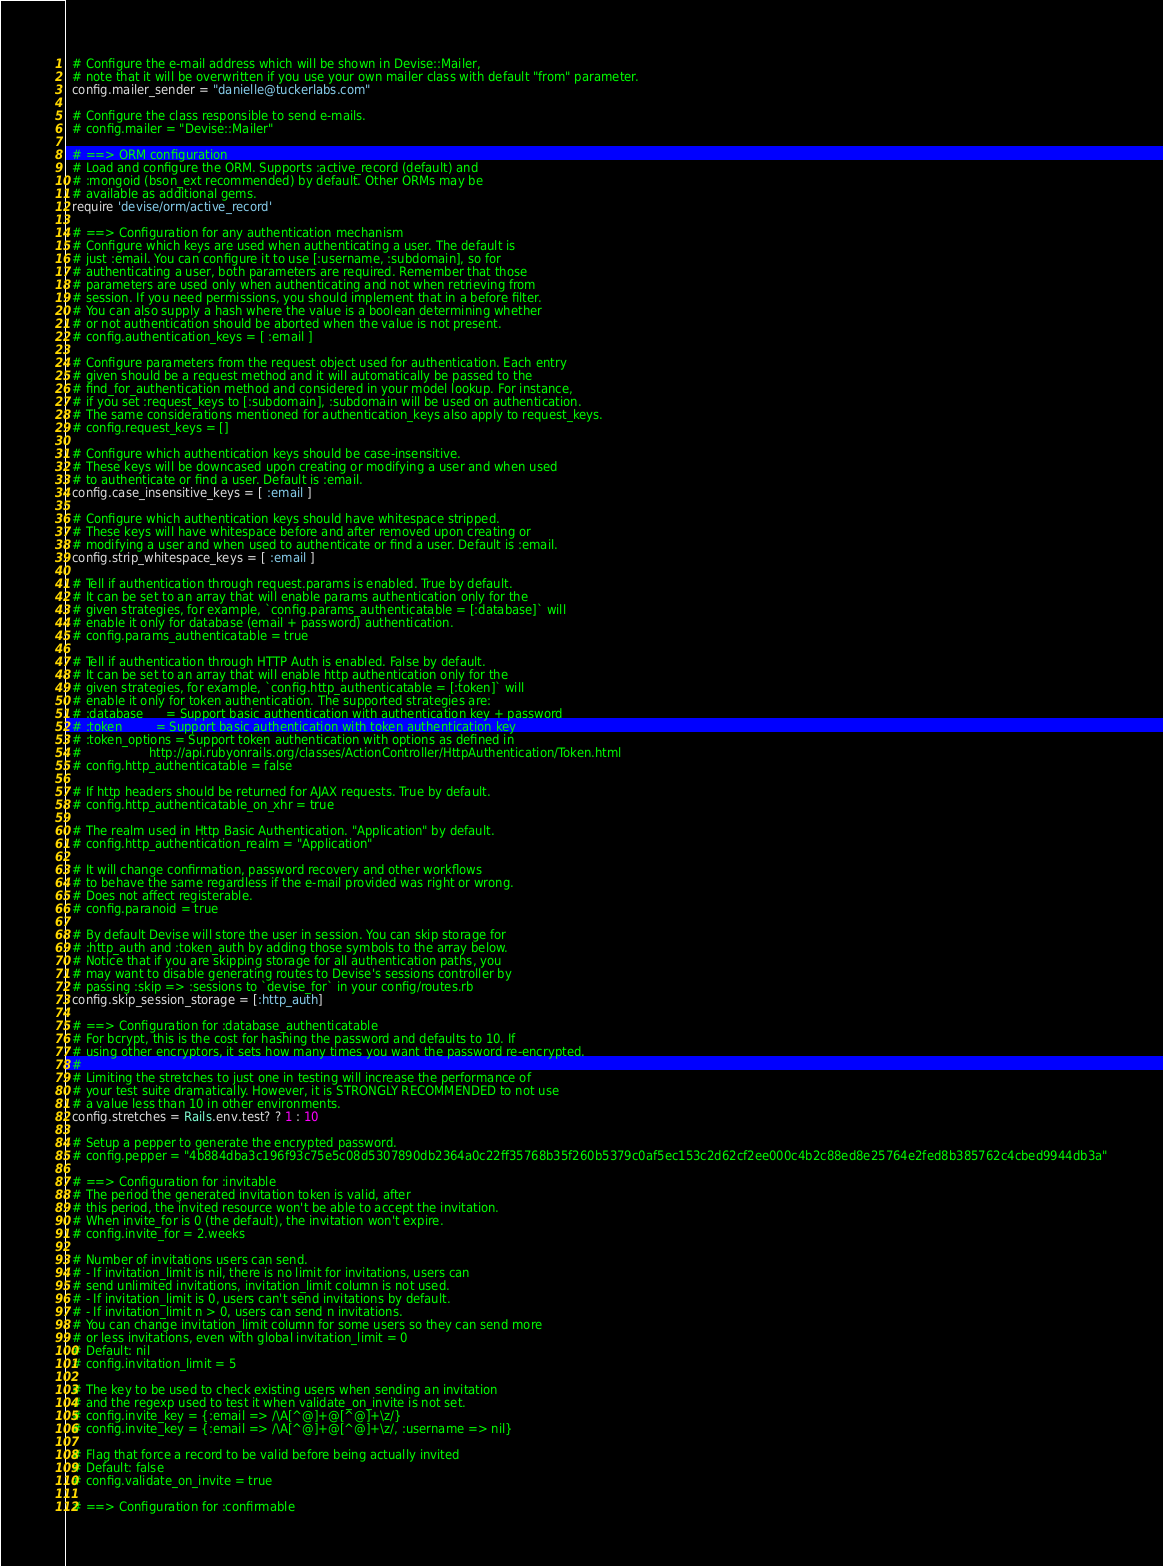<code> <loc_0><loc_0><loc_500><loc_500><_Ruby_>  # Configure the e-mail address which will be shown in Devise::Mailer,
  # note that it will be overwritten if you use your own mailer class with default "from" parameter.
  config.mailer_sender = "danielle@tuckerlabs.com"

  # Configure the class responsible to send e-mails.
  # config.mailer = "Devise::Mailer"

  # ==> ORM configuration
  # Load and configure the ORM. Supports :active_record (default) and
  # :mongoid (bson_ext recommended) by default. Other ORMs may be
  # available as additional gems.
  require 'devise/orm/active_record'

  # ==> Configuration for any authentication mechanism
  # Configure which keys are used when authenticating a user. The default is
  # just :email. You can configure it to use [:username, :subdomain], so for
  # authenticating a user, both parameters are required. Remember that those
  # parameters are used only when authenticating and not when retrieving from
  # session. If you need permissions, you should implement that in a before filter.
  # You can also supply a hash where the value is a boolean determining whether
  # or not authentication should be aborted when the value is not present.
  # config.authentication_keys = [ :email ]

  # Configure parameters from the request object used for authentication. Each entry
  # given should be a request method and it will automatically be passed to the
  # find_for_authentication method and considered in your model lookup. For instance,
  # if you set :request_keys to [:subdomain], :subdomain will be used on authentication.
  # The same considerations mentioned for authentication_keys also apply to request_keys.
  # config.request_keys = []

  # Configure which authentication keys should be case-insensitive.
  # These keys will be downcased upon creating or modifying a user and when used
  # to authenticate or find a user. Default is :email.
  config.case_insensitive_keys = [ :email ]

  # Configure which authentication keys should have whitespace stripped.
  # These keys will have whitespace before and after removed upon creating or
  # modifying a user and when used to authenticate or find a user. Default is :email.
  config.strip_whitespace_keys = [ :email ]

  # Tell if authentication through request.params is enabled. True by default.
  # It can be set to an array that will enable params authentication only for the
  # given strategies, for example, `config.params_authenticatable = [:database]` will
  # enable it only for database (email + password) authentication.
  # config.params_authenticatable = true

  # Tell if authentication through HTTP Auth is enabled. False by default.
  # It can be set to an array that will enable http authentication only for the
  # given strategies, for example, `config.http_authenticatable = [:token]` will
  # enable it only for token authentication. The supported strategies are:
  # :database      = Support basic authentication with authentication key + password
  # :token         = Support basic authentication with token authentication key
  # :token_options = Support token authentication with options as defined in
  #                  http://api.rubyonrails.org/classes/ActionController/HttpAuthentication/Token.html
  # config.http_authenticatable = false

  # If http headers should be returned for AJAX requests. True by default.
  # config.http_authenticatable_on_xhr = true

  # The realm used in Http Basic Authentication. "Application" by default.
  # config.http_authentication_realm = "Application"

  # It will change confirmation, password recovery and other workflows
  # to behave the same regardless if the e-mail provided was right or wrong.
  # Does not affect registerable.
  # config.paranoid = true

  # By default Devise will store the user in session. You can skip storage for
  # :http_auth and :token_auth by adding those symbols to the array below.
  # Notice that if you are skipping storage for all authentication paths, you
  # may want to disable generating routes to Devise's sessions controller by
  # passing :skip => :sessions to `devise_for` in your config/routes.rb
  config.skip_session_storage = [:http_auth]

  # ==> Configuration for :database_authenticatable
  # For bcrypt, this is the cost for hashing the password and defaults to 10. If
  # using other encryptors, it sets how many times you want the password re-encrypted.
  #
  # Limiting the stretches to just one in testing will increase the performance of
  # your test suite dramatically. However, it is STRONGLY RECOMMENDED to not use
  # a value less than 10 in other environments.
  config.stretches = Rails.env.test? ? 1 : 10

  # Setup a pepper to generate the encrypted password.
  # config.pepper = "4b884dba3c196f93c75e5c08d5307890db2364a0c22ff35768b35f260b5379c0af5ec153c2d62cf2ee000c4b2c88ed8e25764e2fed8b385762c4cbed9944db3a"

  # ==> Configuration for :invitable
  # The period the generated invitation token is valid, after
  # this period, the invited resource won't be able to accept the invitation.
  # When invite_for is 0 (the default), the invitation won't expire.
  # config.invite_for = 2.weeks

  # Number of invitations users can send.
  # - If invitation_limit is nil, there is no limit for invitations, users can
  # send unlimited invitations, invitation_limit column is not used.
  # - If invitation_limit is 0, users can't send invitations by default.
  # - If invitation_limit n > 0, users can send n invitations.
  # You can change invitation_limit column for some users so they can send more
  # or less invitations, even with global invitation_limit = 0
  # Default: nil
  # config.invitation_limit = 5

  # The key to be used to check existing users when sending an invitation
  # and the regexp used to test it when validate_on_invite is not set.
  # config.invite_key = {:email => /\A[^@]+@[^@]+\z/}
  # config.invite_key = {:email => /\A[^@]+@[^@]+\z/, :username => nil}

  # Flag that force a record to be valid before being actually invited
  # Default: false
  # config.validate_on_invite = true

  # ==> Configuration for :confirmable</code> 